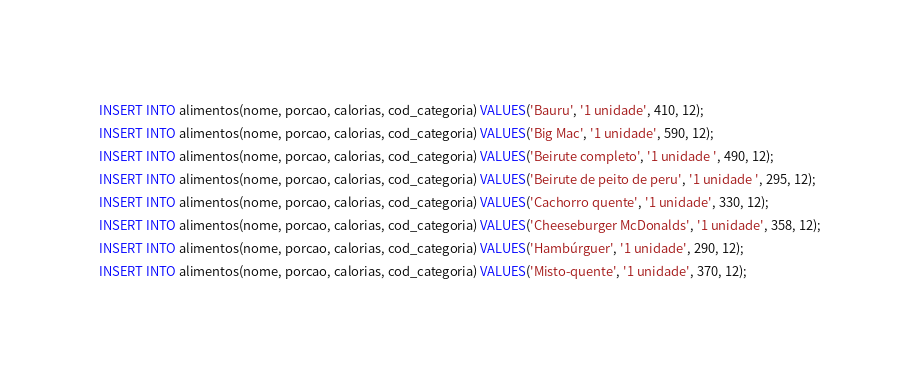Convert code to text. <code><loc_0><loc_0><loc_500><loc_500><_SQL_>INSERT INTO alimentos(nome, porcao, calorias, cod_categoria) VALUES('Bauru', '1 unidade', 410, 12);
INSERT INTO alimentos(nome, porcao, calorias, cod_categoria) VALUES('Big Mac', '1 unidade', 590, 12);
INSERT INTO alimentos(nome, porcao, calorias, cod_categoria) VALUES('Beirute completo', '1 unidade ', 490, 12);
INSERT INTO alimentos(nome, porcao, calorias, cod_categoria) VALUES('Beirute de peito de peru', '1 unidade ', 295, 12);
INSERT INTO alimentos(nome, porcao, calorias, cod_categoria) VALUES('Cachorro quente', '1 unidade', 330, 12);
INSERT INTO alimentos(nome, porcao, calorias, cod_categoria) VALUES('Cheeseburger McDonalds', '1 unidade', 358, 12);
INSERT INTO alimentos(nome, porcao, calorias, cod_categoria) VALUES('Hambúrguer', '1 unidade', 290, 12);
INSERT INTO alimentos(nome, porcao, calorias, cod_categoria) VALUES('Misto-quente', '1 unidade', 370, 12);</code> 